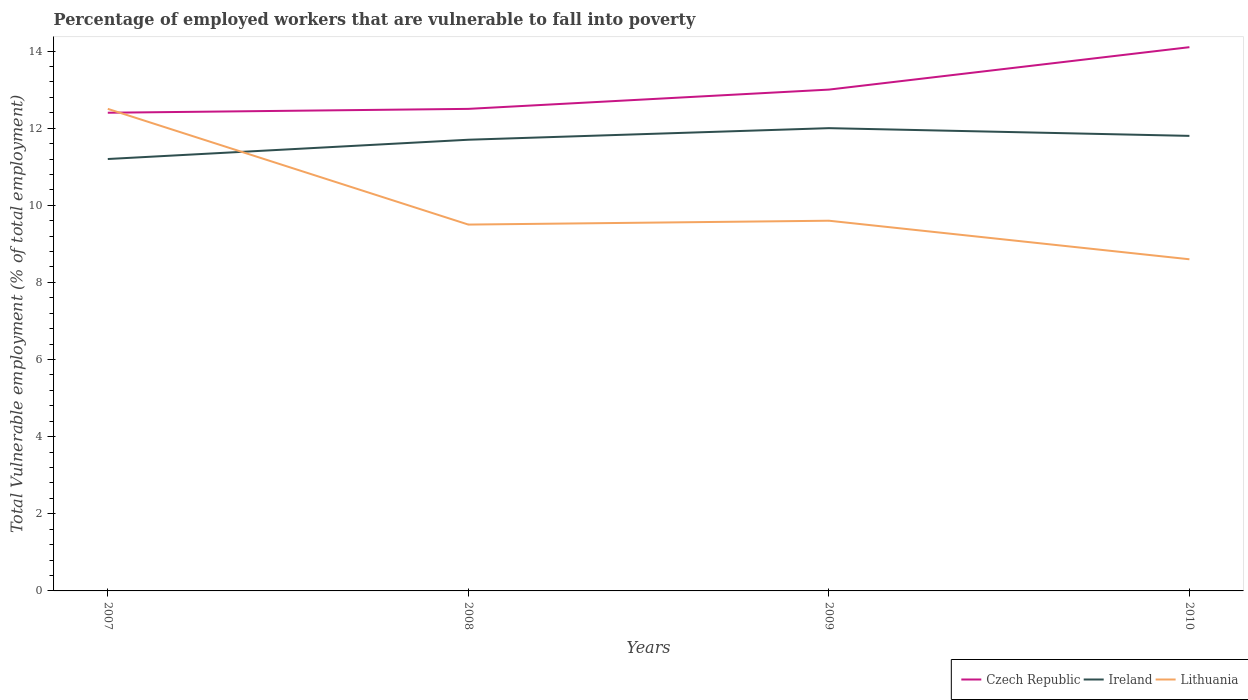How many different coloured lines are there?
Make the answer very short. 3. Across all years, what is the maximum percentage of employed workers who are vulnerable to fall into poverty in Ireland?
Your response must be concise. 11.2. In which year was the percentage of employed workers who are vulnerable to fall into poverty in Lithuania maximum?
Offer a terse response. 2010. What is the total percentage of employed workers who are vulnerable to fall into poverty in Ireland in the graph?
Offer a very short reply. -0.3. What is the difference between the highest and the second highest percentage of employed workers who are vulnerable to fall into poverty in Czech Republic?
Offer a very short reply. 1.7. How many lines are there?
Offer a terse response. 3. How many years are there in the graph?
Ensure brevity in your answer.  4. How many legend labels are there?
Ensure brevity in your answer.  3. What is the title of the graph?
Your response must be concise. Percentage of employed workers that are vulnerable to fall into poverty. What is the label or title of the Y-axis?
Offer a terse response. Total Vulnerable employment (% of total employment). What is the Total Vulnerable employment (% of total employment) of Czech Republic in 2007?
Your answer should be very brief. 12.4. What is the Total Vulnerable employment (% of total employment) in Ireland in 2007?
Your response must be concise. 11.2. What is the Total Vulnerable employment (% of total employment) of Lithuania in 2007?
Offer a terse response. 12.5. What is the Total Vulnerable employment (% of total employment) of Ireland in 2008?
Your answer should be compact. 11.7. What is the Total Vulnerable employment (% of total employment) in Lithuania in 2008?
Your answer should be compact. 9.5. What is the Total Vulnerable employment (% of total employment) of Lithuania in 2009?
Offer a very short reply. 9.6. What is the Total Vulnerable employment (% of total employment) in Czech Republic in 2010?
Your answer should be compact. 14.1. What is the Total Vulnerable employment (% of total employment) of Ireland in 2010?
Give a very brief answer. 11.8. What is the Total Vulnerable employment (% of total employment) in Lithuania in 2010?
Your answer should be very brief. 8.6. Across all years, what is the maximum Total Vulnerable employment (% of total employment) of Czech Republic?
Your answer should be very brief. 14.1. Across all years, what is the maximum Total Vulnerable employment (% of total employment) of Lithuania?
Your answer should be very brief. 12.5. Across all years, what is the minimum Total Vulnerable employment (% of total employment) in Czech Republic?
Your response must be concise. 12.4. Across all years, what is the minimum Total Vulnerable employment (% of total employment) of Ireland?
Offer a very short reply. 11.2. Across all years, what is the minimum Total Vulnerable employment (% of total employment) in Lithuania?
Make the answer very short. 8.6. What is the total Total Vulnerable employment (% of total employment) of Ireland in the graph?
Offer a very short reply. 46.7. What is the total Total Vulnerable employment (% of total employment) of Lithuania in the graph?
Provide a succinct answer. 40.2. What is the difference between the Total Vulnerable employment (% of total employment) in Ireland in 2007 and that in 2008?
Offer a terse response. -0.5. What is the difference between the Total Vulnerable employment (% of total employment) of Lithuania in 2007 and that in 2008?
Your answer should be very brief. 3. What is the difference between the Total Vulnerable employment (% of total employment) of Czech Republic in 2007 and that in 2010?
Your answer should be very brief. -1.7. What is the difference between the Total Vulnerable employment (% of total employment) of Lithuania in 2007 and that in 2010?
Offer a terse response. 3.9. What is the difference between the Total Vulnerable employment (% of total employment) of Lithuania in 2008 and that in 2009?
Ensure brevity in your answer.  -0.1. What is the difference between the Total Vulnerable employment (% of total employment) of Czech Republic in 2008 and that in 2010?
Your answer should be very brief. -1.6. What is the difference between the Total Vulnerable employment (% of total employment) of Ireland in 2008 and that in 2010?
Provide a short and direct response. -0.1. What is the difference between the Total Vulnerable employment (% of total employment) in Lithuania in 2008 and that in 2010?
Offer a very short reply. 0.9. What is the difference between the Total Vulnerable employment (% of total employment) in Ireland in 2009 and that in 2010?
Give a very brief answer. 0.2. What is the difference between the Total Vulnerable employment (% of total employment) in Lithuania in 2009 and that in 2010?
Offer a very short reply. 1. What is the difference between the Total Vulnerable employment (% of total employment) of Czech Republic in 2007 and the Total Vulnerable employment (% of total employment) of Ireland in 2008?
Your answer should be very brief. 0.7. What is the difference between the Total Vulnerable employment (% of total employment) in Czech Republic in 2007 and the Total Vulnerable employment (% of total employment) in Ireland in 2009?
Your answer should be very brief. 0.4. What is the difference between the Total Vulnerable employment (% of total employment) in Czech Republic in 2007 and the Total Vulnerable employment (% of total employment) in Ireland in 2010?
Provide a succinct answer. 0.6. What is the difference between the Total Vulnerable employment (% of total employment) of Czech Republic in 2007 and the Total Vulnerable employment (% of total employment) of Lithuania in 2010?
Provide a short and direct response. 3.8. What is the difference between the Total Vulnerable employment (% of total employment) in Czech Republic in 2008 and the Total Vulnerable employment (% of total employment) in Lithuania in 2009?
Your answer should be compact. 2.9. What is the difference between the Total Vulnerable employment (% of total employment) in Ireland in 2008 and the Total Vulnerable employment (% of total employment) in Lithuania in 2009?
Provide a succinct answer. 2.1. What is the difference between the Total Vulnerable employment (% of total employment) in Czech Republic in 2008 and the Total Vulnerable employment (% of total employment) in Lithuania in 2010?
Make the answer very short. 3.9. What is the difference between the Total Vulnerable employment (% of total employment) in Czech Republic in 2009 and the Total Vulnerable employment (% of total employment) in Lithuania in 2010?
Ensure brevity in your answer.  4.4. What is the average Total Vulnerable employment (% of total employment) of Ireland per year?
Your response must be concise. 11.68. What is the average Total Vulnerable employment (% of total employment) of Lithuania per year?
Your answer should be very brief. 10.05. In the year 2007, what is the difference between the Total Vulnerable employment (% of total employment) of Czech Republic and Total Vulnerable employment (% of total employment) of Lithuania?
Offer a very short reply. -0.1. In the year 2008, what is the difference between the Total Vulnerable employment (% of total employment) of Czech Republic and Total Vulnerable employment (% of total employment) of Lithuania?
Provide a succinct answer. 3. In the year 2009, what is the difference between the Total Vulnerable employment (% of total employment) of Ireland and Total Vulnerable employment (% of total employment) of Lithuania?
Provide a short and direct response. 2.4. In the year 2010, what is the difference between the Total Vulnerable employment (% of total employment) of Czech Republic and Total Vulnerable employment (% of total employment) of Ireland?
Your answer should be compact. 2.3. What is the ratio of the Total Vulnerable employment (% of total employment) of Ireland in 2007 to that in 2008?
Make the answer very short. 0.96. What is the ratio of the Total Vulnerable employment (% of total employment) of Lithuania in 2007 to that in 2008?
Offer a terse response. 1.32. What is the ratio of the Total Vulnerable employment (% of total employment) of Czech Republic in 2007 to that in 2009?
Offer a very short reply. 0.95. What is the ratio of the Total Vulnerable employment (% of total employment) in Ireland in 2007 to that in 2009?
Ensure brevity in your answer.  0.93. What is the ratio of the Total Vulnerable employment (% of total employment) in Lithuania in 2007 to that in 2009?
Your answer should be compact. 1.3. What is the ratio of the Total Vulnerable employment (% of total employment) of Czech Republic in 2007 to that in 2010?
Ensure brevity in your answer.  0.88. What is the ratio of the Total Vulnerable employment (% of total employment) in Ireland in 2007 to that in 2010?
Your answer should be compact. 0.95. What is the ratio of the Total Vulnerable employment (% of total employment) in Lithuania in 2007 to that in 2010?
Offer a terse response. 1.45. What is the ratio of the Total Vulnerable employment (% of total employment) in Czech Republic in 2008 to that in 2009?
Offer a very short reply. 0.96. What is the ratio of the Total Vulnerable employment (% of total employment) of Lithuania in 2008 to that in 2009?
Provide a short and direct response. 0.99. What is the ratio of the Total Vulnerable employment (% of total employment) in Czech Republic in 2008 to that in 2010?
Ensure brevity in your answer.  0.89. What is the ratio of the Total Vulnerable employment (% of total employment) in Lithuania in 2008 to that in 2010?
Offer a terse response. 1.1. What is the ratio of the Total Vulnerable employment (% of total employment) in Czech Republic in 2009 to that in 2010?
Your answer should be very brief. 0.92. What is the ratio of the Total Vulnerable employment (% of total employment) of Ireland in 2009 to that in 2010?
Make the answer very short. 1.02. What is the ratio of the Total Vulnerable employment (% of total employment) of Lithuania in 2009 to that in 2010?
Your answer should be very brief. 1.12. What is the difference between the highest and the second highest Total Vulnerable employment (% of total employment) of Lithuania?
Keep it short and to the point. 2.9. What is the difference between the highest and the lowest Total Vulnerable employment (% of total employment) of Czech Republic?
Your response must be concise. 1.7. 